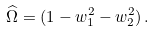Convert formula to latex. <formula><loc_0><loc_0><loc_500><loc_500>\widehat { \Omega } = ( 1 - w _ { 1 } ^ { 2 } - w _ { 2 } ^ { 2 } ) \, .</formula> 